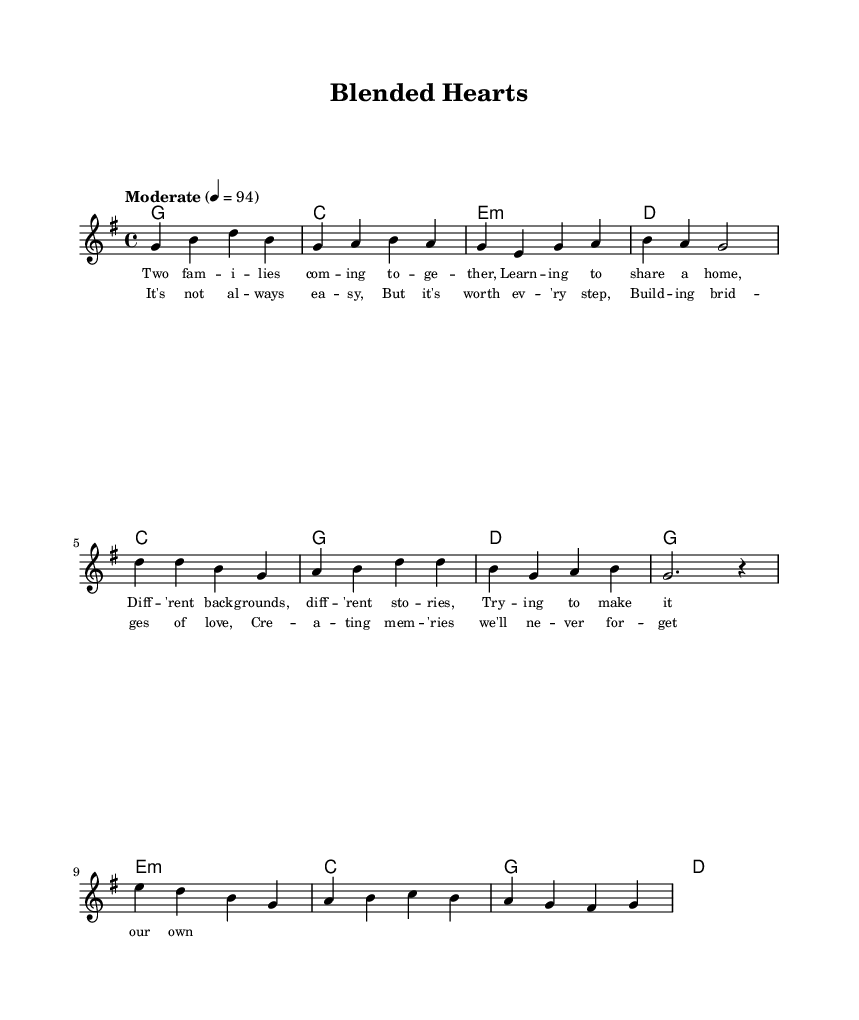What is the key signature of this music? The key signature in the score is G major, which has one sharp, F sharp.
Answer: G major What is the time signature of this piece? The time signature shown in the sheet music is 4/4, which means four beats per measure.
Answer: 4/4 What is the tempo marking for this piece? The tempo marking provided in the score indicates "Moderate" at a speed of 94 beats per minute.
Answer: Moderate 4 = 94 How many measures does the verse contain? The verse includes four measures, as indicated by the notation across the lines in the melody and harmonies sections.
Answer: 4 What is the primary theme expressed in the lyrics? The lyrics focus on the themes of blending families and creating memories, highlighting the challenges and rewards of stepparenting.
Answer: Blending families Which chord follows the first measure of the chorus? The first measure of the chorus is accompanied by the chord C major, as evident in the harmonies section underneath the melody.
Answer: C How does the melody of the bridge differ from the verse? The bridge introduces higher notes and a slightly different progression, emphasizing emotional shifts, contrasting with the more grounded melodies of the verse.
Answer: Higher notes 